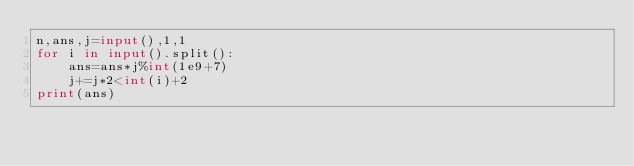Convert code to text. <code><loc_0><loc_0><loc_500><loc_500><_Python_>n,ans,j=input(),1,1
for i in input().split():
	ans=ans*j%int(1e9+7)
	j+=j*2<int(i)+2
print(ans)</code> 